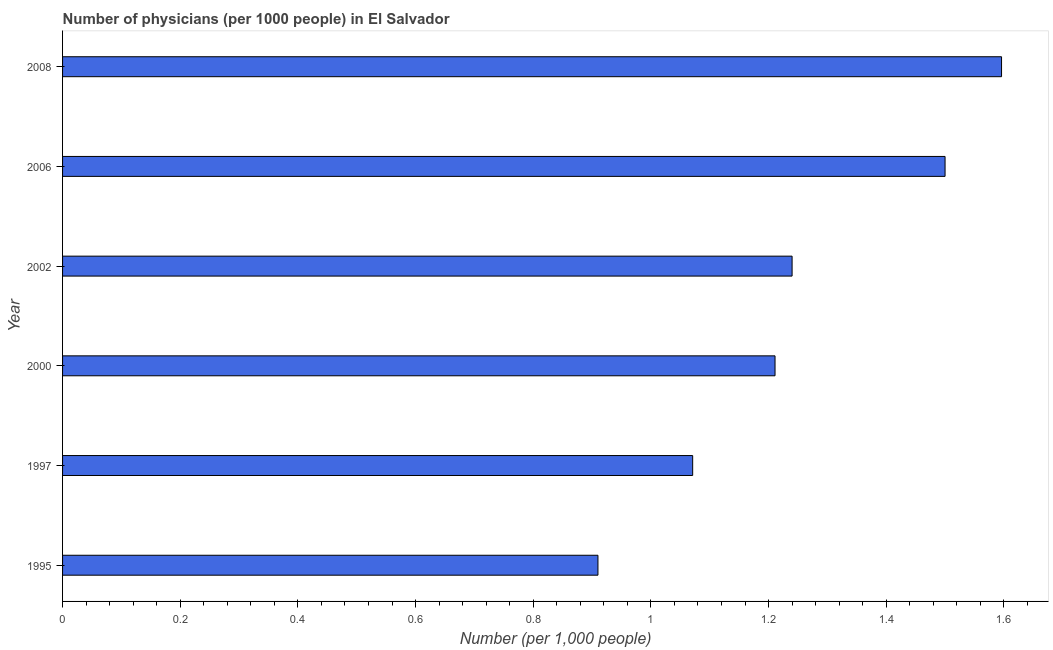Does the graph contain any zero values?
Give a very brief answer. No. Does the graph contain grids?
Your response must be concise. No. What is the title of the graph?
Keep it short and to the point. Number of physicians (per 1000 people) in El Salvador. What is the label or title of the X-axis?
Give a very brief answer. Number (per 1,0 people). What is the number of physicians in 2008?
Your response must be concise. 1.6. Across all years, what is the maximum number of physicians?
Your answer should be compact. 1.6. Across all years, what is the minimum number of physicians?
Your answer should be compact. 0.91. In which year was the number of physicians maximum?
Provide a succinct answer. 2008. What is the sum of the number of physicians?
Keep it short and to the point. 7.53. What is the difference between the number of physicians in 2002 and 2008?
Make the answer very short. -0.36. What is the average number of physicians per year?
Provide a succinct answer. 1.25. What is the median number of physicians?
Give a very brief answer. 1.23. In how many years, is the number of physicians greater than 0.4 ?
Make the answer very short. 6. What is the ratio of the number of physicians in 1997 to that in 2008?
Ensure brevity in your answer.  0.67. Is the difference between the number of physicians in 1995 and 1997 greater than the difference between any two years?
Ensure brevity in your answer.  No. What is the difference between the highest and the second highest number of physicians?
Offer a terse response. 0.1. Is the sum of the number of physicians in 2002 and 2006 greater than the maximum number of physicians across all years?
Your answer should be compact. Yes. What is the difference between the highest and the lowest number of physicians?
Provide a short and direct response. 0.69. In how many years, is the number of physicians greater than the average number of physicians taken over all years?
Ensure brevity in your answer.  2. How many bars are there?
Your response must be concise. 6. Are all the bars in the graph horizontal?
Ensure brevity in your answer.  Yes. How many years are there in the graph?
Make the answer very short. 6. What is the Number (per 1,000 people) in 1995?
Your answer should be compact. 0.91. What is the Number (per 1,000 people) of 1997?
Offer a terse response. 1.07. What is the Number (per 1,000 people) of 2000?
Your answer should be very brief. 1.21. What is the Number (per 1,000 people) of 2002?
Your answer should be compact. 1.24. What is the Number (per 1,000 people) in 2008?
Make the answer very short. 1.6. What is the difference between the Number (per 1,000 people) in 1995 and 1997?
Give a very brief answer. -0.16. What is the difference between the Number (per 1,000 people) in 1995 and 2000?
Your answer should be very brief. -0.3. What is the difference between the Number (per 1,000 people) in 1995 and 2002?
Make the answer very short. -0.33. What is the difference between the Number (per 1,000 people) in 1995 and 2006?
Keep it short and to the point. -0.59. What is the difference between the Number (per 1,000 people) in 1995 and 2008?
Your response must be concise. -0.69. What is the difference between the Number (per 1,000 people) in 1997 and 2000?
Offer a terse response. -0.14. What is the difference between the Number (per 1,000 people) in 1997 and 2002?
Your answer should be very brief. -0.17. What is the difference between the Number (per 1,000 people) in 1997 and 2006?
Make the answer very short. -0.43. What is the difference between the Number (per 1,000 people) in 1997 and 2008?
Keep it short and to the point. -0.53. What is the difference between the Number (per 1,000 people) in 2000 and 2002?
Provide a short and direct response. -0.03. What is the difference between the Number (per 1,000 people) in 2000 and 2006?
Ensure brevity in your answer.  -0.29. What is the difference between the Number (per 1,000 people) in 2000 and 2008?
Offer a terse response. -0.39. What is the difference between the Number (per 1,000 people) in 2002 and 2006?
Ensure brevity in your answer.  -0.26. What is the difference between the Number (per 1,000 people) in 2002 and 2008?
Your answer should be very brief. -0.36. What is the difference between the Number (per 1,000 people) in 2006 and 2008?
Offer a terse response. -0.1. What is the ratio of the Number (per 1,000 people) in 1995 to that in 2000?
Keep it short and to the point. 0.75. What is the ratio of the Number (per 1,000 people) in 1995 to that in 2002?
Provide a succinct answer. 0.73. What is the ratio of the Number (per 1,000 people) in 1995 to that in 2006?
Make the answer very short. 0.61. What is the ratio of the Number (per 1,000 people) in 1995 to that in 2008?
Provide a succinct answer. 0.57. What is the ratio of the Number (per 1,000 people) in 1997 to that in 2000?
Your response must be concise. 0.88. What is the ratio of the Number (per 1,000 people) in 1997 to that in 2002?
Offer a very short reply. 0.86. What is the ratio of the Number (per 1,000 people) in 1997 to that in 2006?
Provide a succinct answer. 0.71. What is the ratio of the Number (per 1,000 people) in 1997 to that in 2008?
Ensure brevity in your answer.  0.67. What is the ratio of the Number (per 1,000 people) in 2000 to that in 2006?
Keep it short and to the point. 0.81. What is the ratio of the Number (per 1,000 people) in 2000 to that in 2008?
Offer a terse response. 0.76. What is the ratio of the Number (per 1,000 people) in 2002 to that in 2006?
Your answer should be very brief. 0.83. What is the ratio of the Number (per 1,000 people) in 2002 to that in 2008?
Keep it short and to the point. 0.78. What is the ratio of the Number (per 1,000 people) in 2006 to that in 2008?
Offer a terse response. 0.94. 